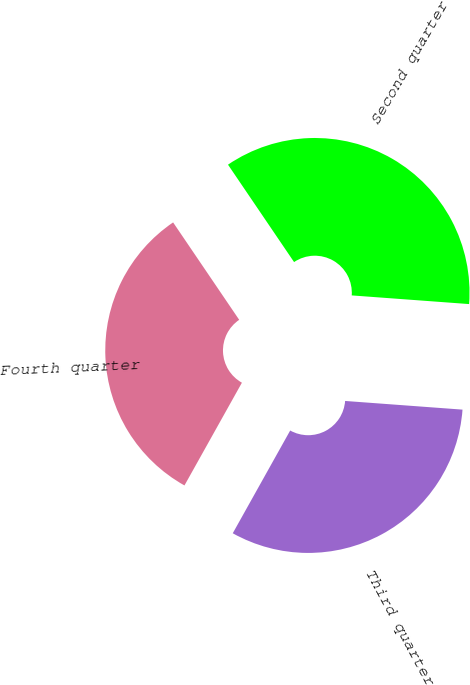Convert chart. <chart><loc_0><loc_0><loc_500><loc_500><pie_chart><fcel>Second quarter<fcel>Third quarter<fcel>Fourth quarter<nl><fcel>35.66%<fcel>31.94%<fcel>32.4%<nl></chart> 